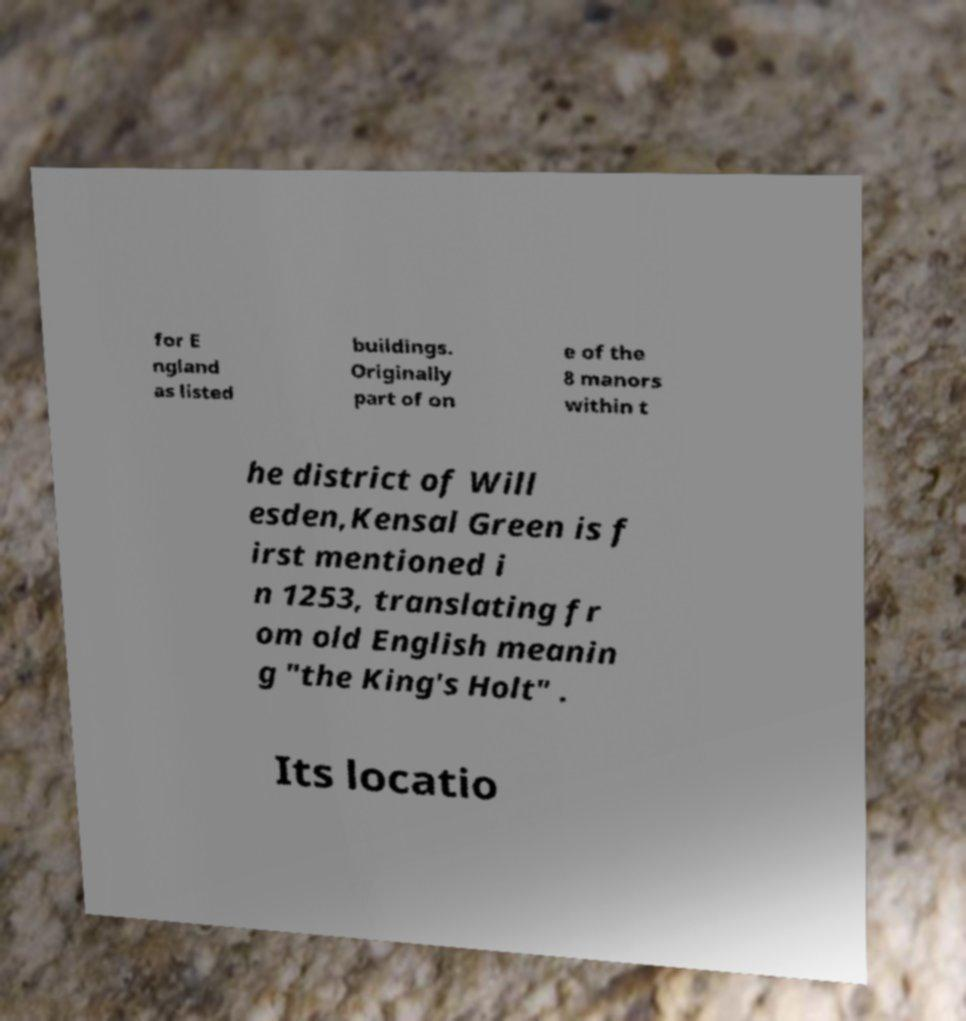Please read and relay the text visible in this image. What does it say? for E ngland as listed buildings. Originally part of on e of the 8 manors within t he district of Will esden,Kensal Green is f irst mentioned i n 1253, translating fr om old English meanin g "the King's Holt" . Its locatio 